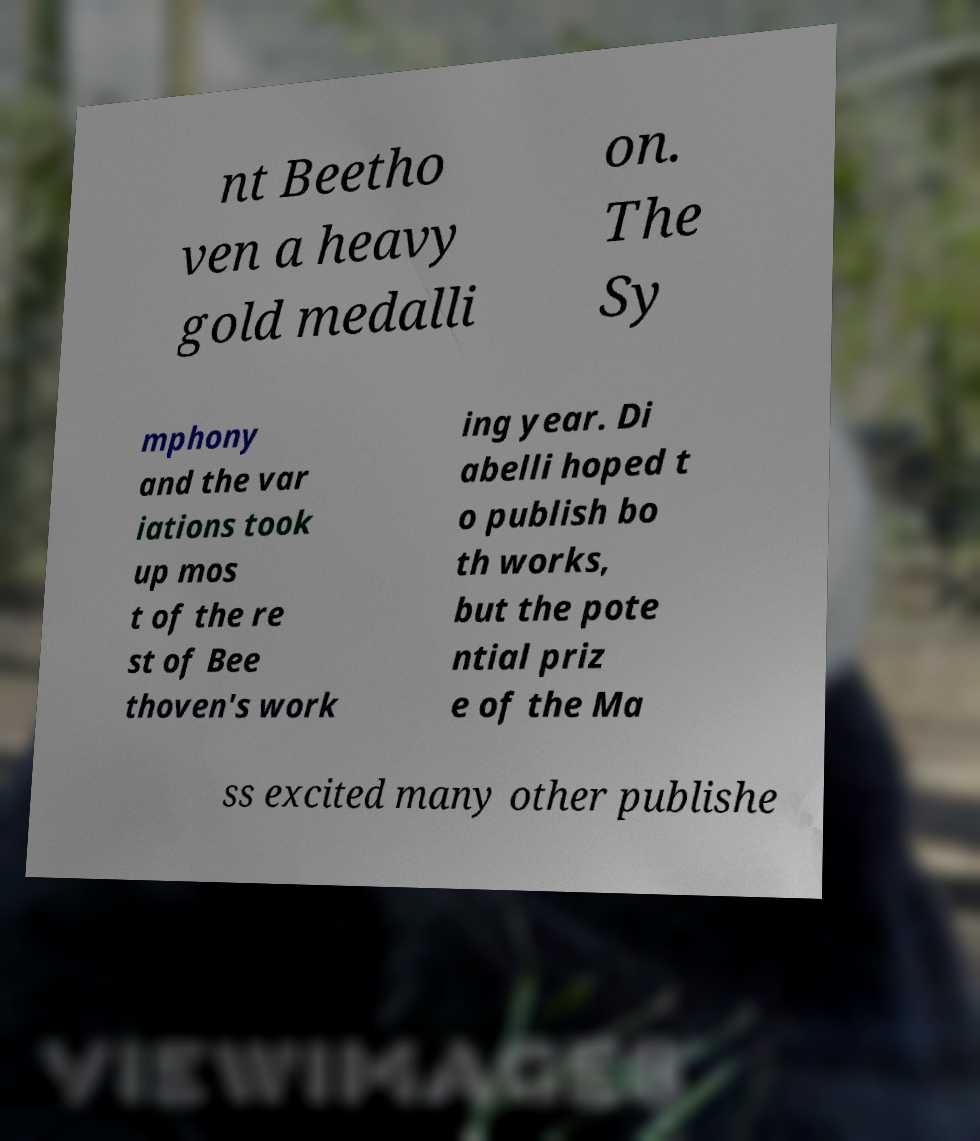What messages or text are displayed in this image? I need them in a readable, typed format. nt Beetho ven a heavy gold medalli on. The Sy mphony and the var iations took up mos t of the re st of Bee thoven's work ing year. Di abelli hoped t o publish bo th works, but the pote ntial priz e of the Ma ss excited many other publishe 